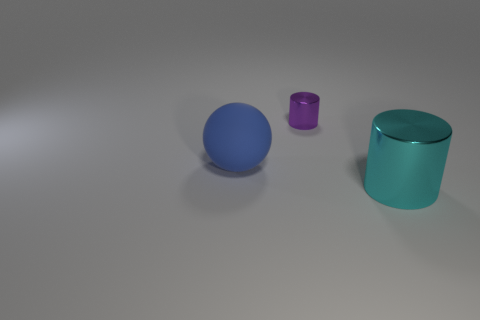Are there any other things that have the same size as the purple metallic cylinder?
Make the answer very short. No. The thing that is both behind the large metallic cylinder and in front of the purple object has what shape?
Offer a terse response. Sphere. What material is the cylinder that is behind the shiny object that is to the right of the metallic cylinder that is to the left of the big cyan metallic cylinder?
Give a very brief answer. Metal. Are there more big cyan cylinders that are to the right of the large ball than big blue rubber spheres behind the tiny object?
Ensure brevity in your answer.  Yes. What number of blue spheres are made of the same material as the purple object?
Your answer should be compact. 0. There is a large thing in front of the blue ball; does it have the same shape as the metallic object behind the rubber ball?
Give a very brief answer. Yes. There is a metallic cylinder to the left of the cyan cylinder; what color is it?
Your answer should be very brief. Purple. Are there any small red things of the same shape as the cyan shiny object?
Your answer should be compact. No. What material is the sphere?
Provide a succinct answer. Rubber. There is a thing that is in front of the tiny purple metal object and on the right side of the big rubber ball; how big is it?
Ensure brevity in your answer.  Large. 